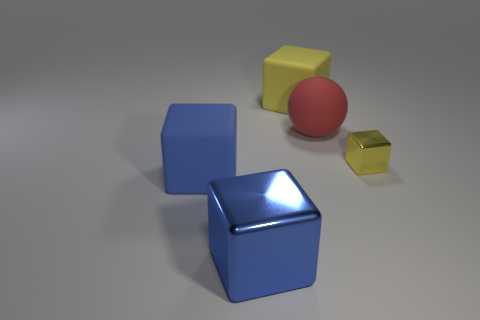Subtract 1 cubes. How many cubes are left? 3 Add 4 metal things. How many objects exist? 9 Subtract all blocks. How many objects are left? 1 Subtract all balls. Subtract all yellow blocks. How many objects are left? 2 Add 2 big yellow blocks. How many big yellow blocks are left? 3 Add 5 yellow rubber cubes. How many yellow rubber cubes exist? 6 Subtract 0 red cylinders. How many objects are left? 5 